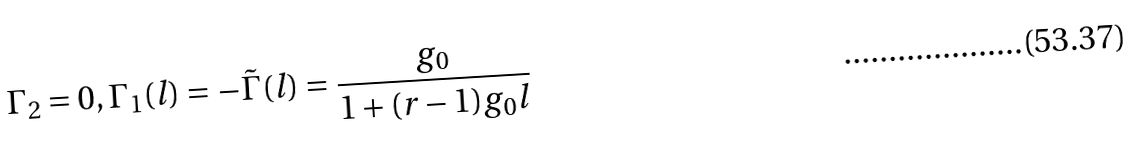<formula> <loc_0><loc_0><loc_500><loc_500>\Gamma _ { 2 } = 0 , \Gamma _ { 1 } ( l ) = - \tilde { \Gamma } ( l ) = \frac { g _ { 0 } } { 1 + ( r - 1 ) g _ { 0 } l }</formula> 